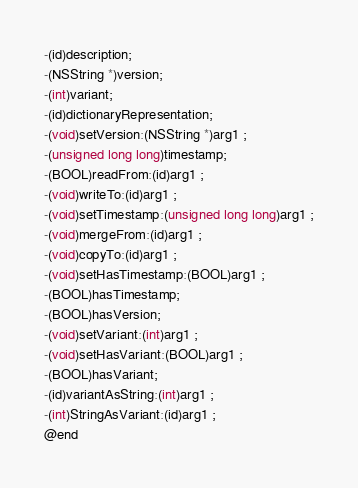Convert code to text. <code><loc_0><loc_0><loc_500><loc_500><_C_>-(id)description;
-(NSString *)version;
-(int)variant;
-(id)dictionaryRepresentation;
-(void)setVersion:(NSString *)arg1 ;
-(unsigned long long)timestamp;
-(BOOL)readFrom:(id)arg1 ;
-(void)writeTo:(id)arg1 ;
-(void)setTimestamp:(unsigned long long)arg1 ;
-(void)mergeFrom:(id)arg1 ;
-(void)copyTo:(id)arg1 ;
-(void)setHasTimestamp:(BOOL)arg1 ;
-(BOOL)hasTimestamp;
-(BOOL)hasVersion;
-(void)setVariant:(int)arg1 ;
-(void)setHasVariant:(BOOL)arg1 ;
-(BOOL)hasVariant;
-(id)variantAsString:(int)arg1 ;
-(int)StringAsVariant:(id)arg1 ;
@end

</code> 